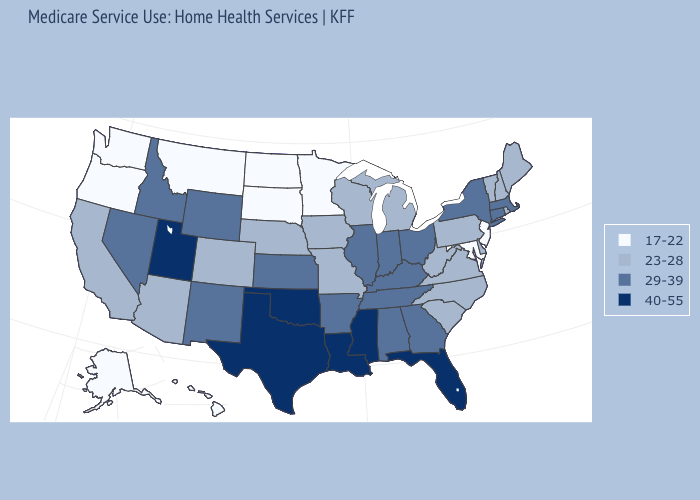Name the states that have a value in the range 23-28?
Quick response, please. Arizona, California, Colorado, Delaware, Iowa, Maine, Michigan, Missouri, Nebraska, New Hampshire, North Carolina, Pennsylvania, Rhode Island, South Carolina, Vermont, Virginia, West Virginia, Wisconsin. Does Vermont have a lower value than Iowa?
Answer briefly. No. What is the lowest value in the Northeast?
Give a very brief answer. 17-22. What is the lowest value in the USA?
Give a very brief answer. 17-22. Does Pennsylvania have the highest value in the USA?
Give a very brief answer. No. Does New Mexico have a lower value than Mississippi?
Quick response, please. Yes. Does Kansas have the highest value in the USA?
Give a very brief answer. No. What is the lowest value in the West?
Be succinct. 17-22. What is the highest value in the USA?
Give a very brief answer. 40-55. Among the states that border New York , does New Jersey have the lowest value?
Keep it brief. Yes. What is the value of Alabama?
Write a very short answer. 29-39. Does Iowa have the highest value in the USA?
Short answer required. No. Which states have the highest value in the USA?
Answer briefly. Florida, Louisiana, Mississippi, Oklahoma, Texas, Utah. Name the states that have a value in the range 40-55?
Quick response, please. Florida, Louisiana, Mississippi, Oklahoma, Texas, Utah. 